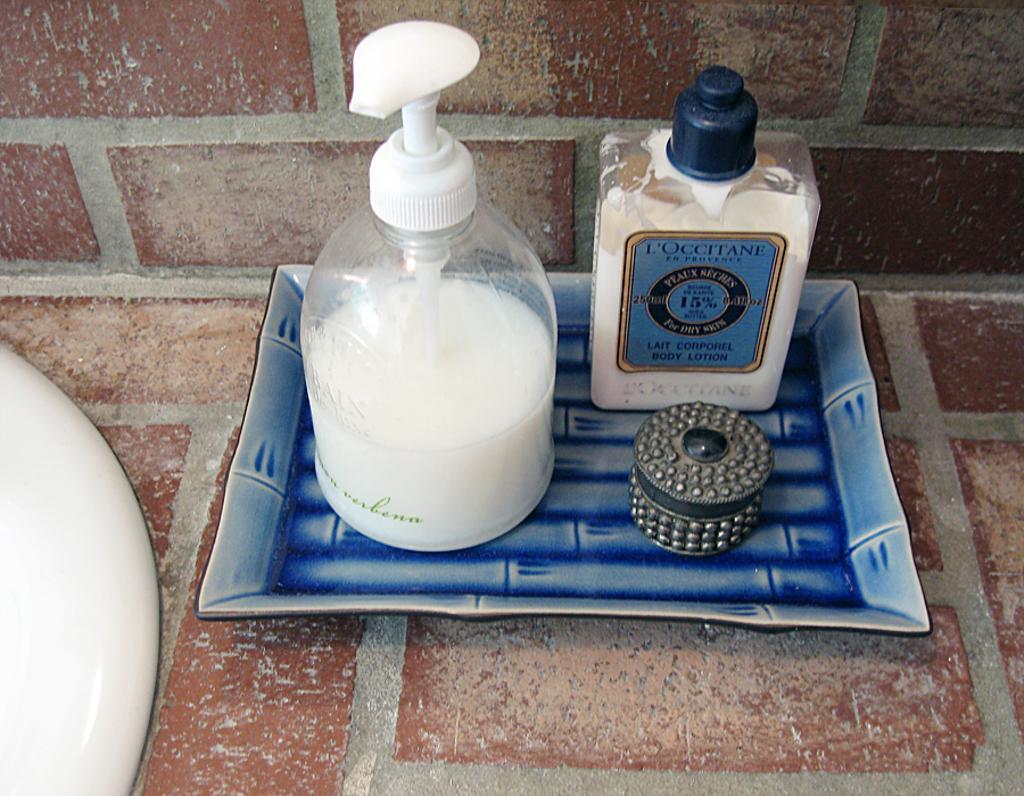In one or two sentences, can you explain what this image depicts? In a plate there are two bottles with white color solution and there is small box with metal body. 